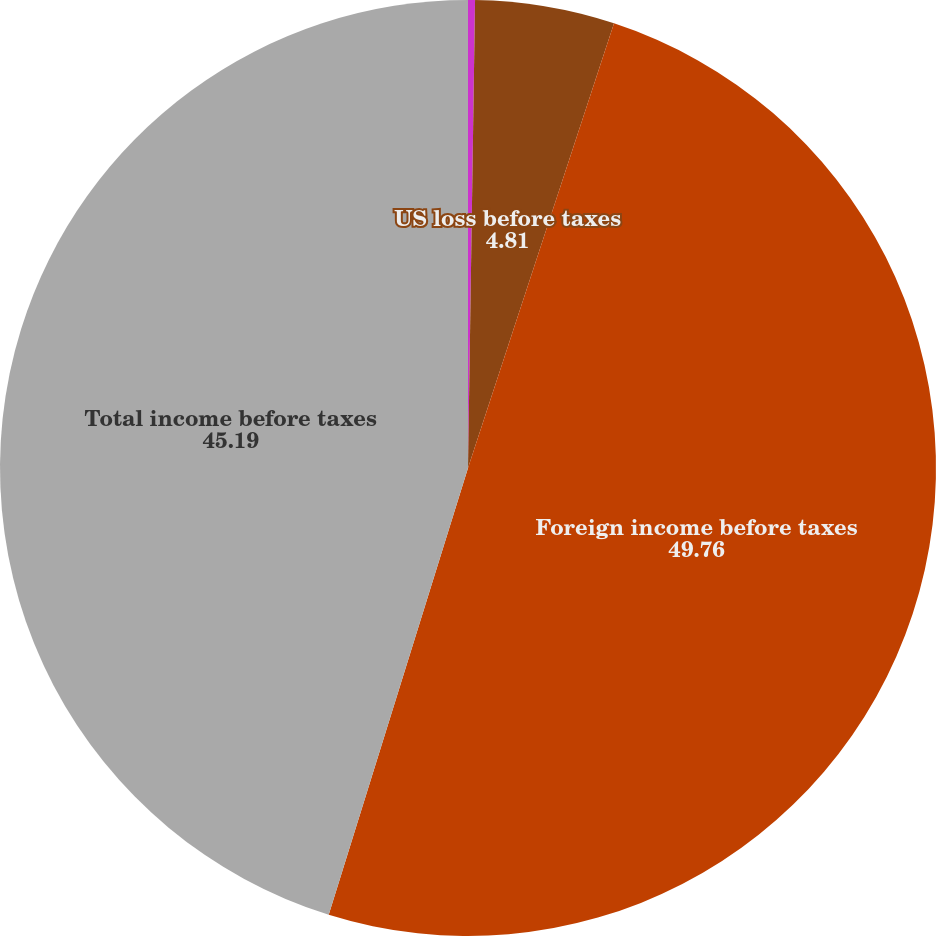Convert chart. <chart><loc_0><loc_0><loc_500><loc_500><pie_chart><fcel>(DOLLARS IN THOUSANDS)<fcel>US loss before taxes<fcel>Foreign income before taxes<fcel>Total income before taxes<nl><fcel>0.24%<fcel>4.81%<fcel>49.76%<fcel>45.19%<nl></chart> 